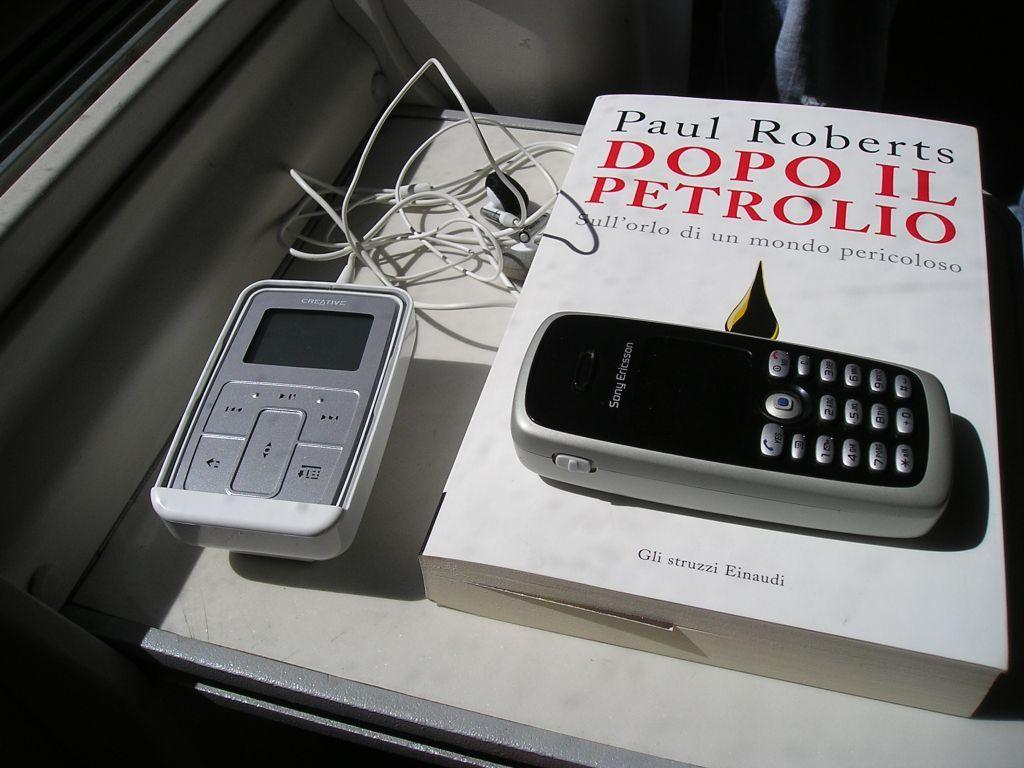Provide a one-sentence caption for the provided image. An mp3 player, a cell phone, and a Paul Roberts book are on a table. 